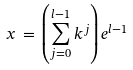Convert formula to latex. <formula><loc_0><loc_0><loc_500><loc_500>x \, = \, \left ( \sum _ { j = 0 } ^ { l - 1 } k ^ { j } \right ) e ^ { l - 1 }</formula> 